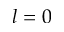Convert formula to latex. <formula><loc_0><loc_0><loc_500><loc_500>l = 0</formula> 